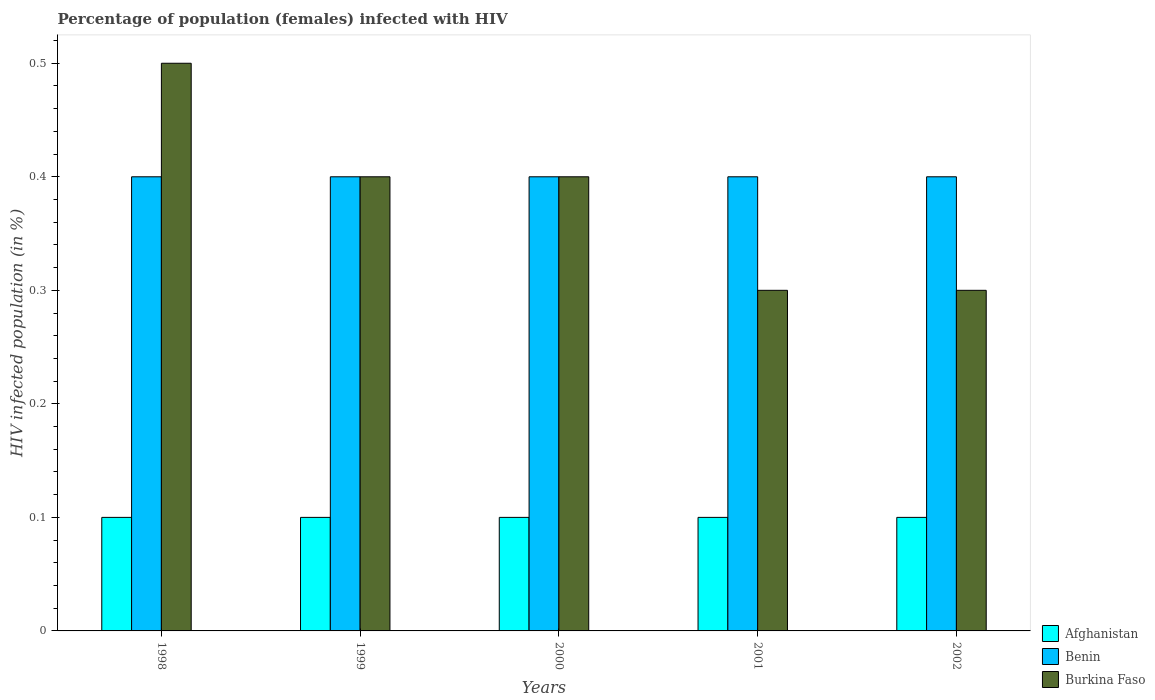Are the number of bars per tick equal to the number of legend labels?
Keep it short and to the point. Yes. Are the number of bars on each tick of the X-axis equal?
Make the answer very short. Yes. How many bars are there on the 4th tick from the right?
Give a very brief answer. 3. What is the label of the 5th group of bars from the left?
Keep it short and to the point. 2002. What is the percentage of HIV infected female population in Burkina Faso in 2001?
Your answer should be compact. 0.3. Across all years, what is the maximum percentage of HIV infected female population in Benin?
Make the answer very short. 0.4. Across all years, what is the minimum percentage of HIV infected female population in Afghanistan?
Give a very brief answer. 0.1. What is the total percentage of HIV infected female population in Burkina Faso in the graph?
Offer a very short reply. 1.9. What is the average percentage of HIV infected female population in Burkina Faso per year?
Your answer should be very brief. 0.38. In the year 2000, what is the difference between the percentage of HIV infected female population in Afghanistan and percentage of HIV infected female population in Benin?
Ensure brevity in your answer.  -0.3. In how many years, is the percentage of HIV infected female population in Burkina Faso greater than 0.48000000000000004 %?
Give a very brief answer. 1. Is the percentage of HIV infected female population in Afghanistan in 1998 less than that in 2002?
Provide a succinct answer. No. Is the difference between the percentage of HIV infected female population in Afghanistan in 1998 and 2001 greater than the difference between the percentage of HIV infected female population in Benin in 1998 and 2001?
Your response must be concise. No. What is the difference between the highest and the second highest percentage of HIV infected female population in Burkina Faso?
Your answer should be very brief. 0.1. What is the difference between the highest and the lowest percentage of HIV infected female population in Benin?
Ensure brevity in your answer.  0. Is the sum of the percentage of HIV infected female population in Benin in 1998 and 2000 greater than the maximum percentage of HIV infected female population in Burkina Faso across all years?
Give a very brief answer. Yes. What does the 1st bar from the left in 1999 represents?
Make the answer very short. Afghanistan. What does the 3rd bar from the right in 1998 represents?
Your answer should be very brief. Afghanistan. How many bars are there?
Keep it short and to the point. 15. Are all the bars in the graph horizontal?
Give a very brief answer. No. How many years are there in the graph?
Your answer should be very brief. 5. What is the difference between two consecutive major ticks on the Y-axis?
Provide a short and direct response. 0.1. Are the values on the major ticks of Y-axis written in scientific E-notation?
Your answer should be compact. No. Does the graph contain any zero values?
Give a very brief answer. No. Does the graph contain grids?
Your answer should be compact. No. Where does the legend appear in the graph?
Give a very brief answer. Bottom right. How are the legend labels stacked?
Your answer should be compact. Vertical. What is the title of the graph?
Offer a very short reply. Percentage of population (females) infected with HIV. Does "Armenia" appear as one of the legend labels in the graph?
Offer a very short reply. No. What is the label or title of the Y-axis?
Offer a terse response. HIV infected population (in %). What is the HIV infected population (in %) in Afghanistan in 1998?
Your answer should be very brief. 0.1. What is the HIV infected population (in %) of Burkina Faso in 1998?
Offer a very short reply. 0.5. What is the HIV infected population (in %) in Benin in 1999?
Keep it short and to the point. 0.4. What is the HIV infected population (in %) in Burkina Faso in 1999?
Give a very brief answer. 0.4. What is the HIV infected population (in %) of Burkina Faso in 2000?
Give a very brief answer. 0.4. What is the HIV infected population (in %) in Benin in 2001?
Make the answer very short. 0.4. What is the HIV infected population (in %) in Burkina Faso in 2001?
Offer a terse response. 0.3. What is the HIV infected population (in %) in Afghanistan in 2002?
Offer a terse response. 0.1. What is the HIV infected population (in %) in Burkina Faso in 2002?
Your response must be concise. 0.3. Across all years, what is the maximum HIV infected population (in %) in Benin?
Offer a very short reply. 0.4. Across all years, what is the maximum HIV infected population (in %) in Burkina Faso?
Ensure brevity in your answer.  0.5. Across all years, what is the minimum HIV infected population (in %) of Afghanistan?
Keep it short and to the point. 0.1. Across all years, what is the minimum HIV infected population (in %) of Benin?
Offer a very short reply. 0.4. What is the total HIV infected population (in %) in Afghanistan in the graph?
Keep it short and to the point. 0.5. What is the total HIV infected population (in %) in Burkina Faso in the graph?
Offer a very short reply. 1.9. What is the difference between the HIV infected population (in %) in Benin in 1998 and that in 1999?
Provide a succinct answer. 0. What is the difference between the HIV infected population (in %) of Burkina Faso in 1998 and that in 2000?
Ensure brevity in your answer.  0.1. What is the difference between the HIV infected population (in %) of Burkina Faso in 1999 and that in 2000?
Your response must be concise. 0. What is the difference between the HIV infected population (in %) of Afghanistan in 1999 and that in 2001?
Offer a very short reply. 0. What is the difference between the HIV infected population (in %) of Benin in 1999 and that in 2002?
Your response must be concise. 0. What is the difference between the HIV infected population (in %) of Afghanistan in 2000 and that in 2001?
Provide a short and direct response. 0. What is the difference between the HIV infected population (in %) in Benin in 2000 and that in 2001?
Keep it short and to the point. 0. What is the difference between the HIV infected population (in %) of Burkina Faso in 2000 and that in 2001?
Your answer should be very brief. 0.1. What is the difference between the HIV infected population (in %) of Afghanistan in 2000 and that in 2002?
Offer a terse response. 0. What is the difference between the HIV infected population (in %) of Benin in 2000 and that in 2002?
Offer a very short reply. 0. What is the difference between the HIV infected population (in %) of Afghanistan in 2001 and that in 2002?
Your response must be concise. 0. What is the difference between the HIV infected population (in %) of Benin in 2001 and that in 2002?
Your answer should be compact. 0. What is the difference between the HIV infected population (in %) of Burkina Faso in 2001 and that in 2002?
Keep it short and to the point. 0. What is the difference between the HIV infected population (in %) in Afghanistan in 1998 and the HIV infected population (in %) in Benin in 1999?
Give a very brief answer. -0.3. What is the difference between the HIV infected population (in %) of Afghanistan in 1998 and the HIV infected population (in %) of Burkina Faso in 1999?
Ensure brevity in your answer.  -0.3. What is the difference between the HIV infected population (in %) of Afghanistan in 1998 and the HIV infected population (in %) of Burkina Faso in 2000?
Make the answer very short. -0.3. What is the difference between the HIV infected population (in %) in Afghanistan in 1998 and the HIV infected population (in %) in Benin in 2001?
Offer a very short reply. -0.3. What is the difference between the HIV infected population (in %) in Afghanistan in 1998 and the HIV infected population (in %) in Burkina Faso in 2002?
Offer a very short reply. -0.2. What is the difference between the HIV infected population (in %) in Benin in 1998 and the HIV infected population (in %) in Burkina Faso in 2002?
Ensure brevity in your answer.  0.1. What is the difference between the HIV infected population (in %) in Afghanistan in 1999 and the HIV infected population (in %) in Benin in 2000?
Give a very brief answer. -0.3. What is the difference between the HIV infected population (in %) of Afghanistan in 1999 and the HIV infected population (in %) of Benin in 2001?
Your answer should be very brief. -0.3. What is the difference between the HIV infected population (in %) of Afghanistan in 1999 and the HIV infected population (in %) of Burkina Faso in 2001?
Give a very brief answer. -0.2. What is the difference between the HIV infected population (in %) of Benin in 1999 and the HIV infected population (in %) of Burkina Faso in 2001?
Your response must be concise. 0.1. What is the difference between the HIV infected population (in %) in Afghanistan in 1999 and the HIV infected population (in %) in Benin in 2002?
Make the answer very short. -0.3. What is the difference between the HIV infected population (in %) of Afghanistan in 1999 and the HIV infected population (in %) of Burkina Faso in 2002?
Make the answer very short. -0.2. What is the difference between the HIV infected population (in %) in Afghanistan in 2000 and the HIV infected population (in %) in Benin in 2002?
Your answer should be very brief. -0.3. What is the difference between the HIV infected population (in %) in Afghanistan in 2000 and the HIV infected population (in %) in Burkina Faso in 2002?
Make the answer very short. -0.2. What is the difference between the HIV infected population (in %) in Benin in 2000 and the HIV infected population (in %) in Burkina Faso in 2002?
Provide a succinct answer. 0.1. What is the difference between the HIV infected population (in %) of Afghanistan in 2001 and the HIV infected population (in %) of Burkina Faso in 2002?
Provide a short and direct response. -0.2. What is the difference between the HIV infected population (in %) in Benin in 2001 and the HIV infected population (in %) in Burkina Faso in 2002?
Your answer should be compact. 0.1. What is the average HIV infected population (in %) of Benin per year?
Provide a short and direct response. 0.4. What is the average HIV infected population (in %) of Burkina Faso per year?
Keep it short and to the point. 0.38. In the year 1998, what is the difference between the HIV infected population (in %) in Afghanistan and HIV infected population (in %) in Burkina Faso?
Provide a succinct answer. -0.4. In the year 1998, what is the difference between the HIV infected population (in %) of Benin and HIV infected population (in %) of Burkina Faso?
Ensure brevity in your answer.  -0.1. In the year 1999, what is the difference between the HIV infected population (in %) of Afghanistan and HIV infected population (in %) of Benin?
Offer a very short reply. -0.3. In the year 2000, what is the difference between the HIV infected population (in %) of Afghanistan and HIV infected population (in %) of Benin?
Offer a terse response. -0.3. In the year 2000, what is the difference between the HIV infected population (in %) in Afghanistan and HIV infected population (in %) in Burkina Faso?
Ensure brevity in your answer.  -0.3. In the year 2000, what is the difference between the HIV infected population (in %) of Benin and HIV infected population (in %) of Burkina Faso?
Your response must be concise. 0. In the year 2001, what is the difference between the HIV infected population (in %) of Benin and HIV infected population (in %) of Burkina Faso?
Your answer should be very brief. 0.1. In the year 2002, what is the difference between the HIV infected population (in %) of Benin and HIV infected population (in %) of Burkina Faso?
Provide a succinct answer. 0.1. What is the ratio of the HIV infected population (in %) of Benin in 1998 to that in 2000?
Keep it short and to the point. 1. What is the ratio of the HIV infected population (in %) of Afghanistan in 1998 to that in 2001?
Provide a short and direct response. 1. What is the ratio of the HIV infected population (in %) of Afghanistan in 1998 to that in 2002?
Ensure brevity in your answer.  1. What is the ratio of the HIV infected population (in %) in Benin in 1998 to that in 2002?
Keep it short and to the point. 1. What is the ratio of the HIV infected population (in %) in Afghanistan in 1999 to that in 2000?
Offer a very short reply. 1. What is the ratio of the HIV infected population (in %) in Benin in 1999 to that in 2000?
Offer a very short reply. 1. What is the ratio of the HIV infected population (in %) of Afghanistan in 1999 to that in 2001?
Make the answer very short. 1. What is the ratio of the HIV infected population (in %) in Burkina Faso in 1999 to that in 2001?
Provide a succinct answer. 1.33. What is the ratio of the HIV infected population (in %) of Burkina Faso in 1999 to that in 2002?
Your response must be concise. 1.33. What is the ratio of the HIV infected population (in %) in Burkina Faso in 2000 to that in 2001?
Your answer should be compact. 1.33. What is the ratio of the HIV infected population (in %) of Afghanistan in 2000 to that in 2002?
Offer a terse response. 1. What is the ratio of the HIV infected population (in %) of Benin in 2000 to that in 2002?
Your response must be concise. 1. What is the ratio of the HIV infected population (in %) in Benin in 2001 to that in 2002?
Offer a terse response. 1. What is the ratio of the HIV infected population (in %) in Burkina Faso in 2001 to that in 2002?
Give a very brief answer. 1. What is the difference between the highest and the second highest HIV infected population (in %) in Afghanistan?
Your answer should be very brief. 0. What is the difference between the highest and the second highest HIV infected population (in %) of Benin?
Keep it short and to the point. 0. What is the difference between the highest and the second highest HIV infected population (in %) of Burkina Faso?
Give a very brief answer. 0.1. What is the difference between the highest and the lowest HIV infected population (in %) of Benin?
Ensure brevity in your answer.  0. 